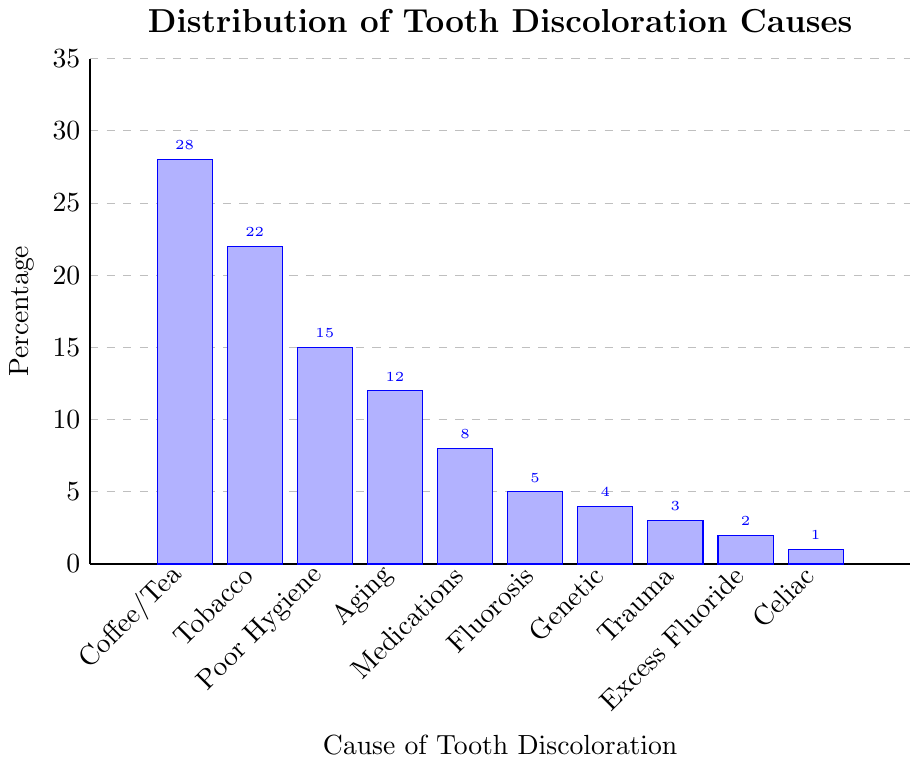Which cause of tooth discoloration has the highest percentage? The bar representing the cause "Coffee/Tea Stains" is the tallest, indicating that it has the highest percentage.
Answer: Coffee/Tea Stains What is the total percentage of tooth discoloration causes due to poor oral hygiene and aging? From the chart, Poor Oral Hygiene is 15% and Aging is 12%. Adding these values together gives 15% + 12% = 27%.
Answer: 27% Which cause of tooth discoloration has the lowest percentage? The bar representing "Celiac Disease" is the shortest, indicating that it has the lowest percentage.
Answer: Celiac Disease How much greater is the percentage of discoloration caused by Tobacco Use compared to Genetic Factors? The percentage for Tobacco Use is 22% and for Genetic Factors is 4%. The difference is 22% - 4% = 18%.
Answer: 18% What is the median percentage value of the displayed causes of tooth discoloration? Arrange the percentages in ascending order: 1, 2, 3, 4, 5, 8, 12, 15, 22, 28. The median is the average of the middle two values (5 and 8), so (5+8)/2 = 6.5%.
Answer: 6.5% Which of the two causes, Fluorosis or Medications, has a higher percentage and by how much? Fluorosis is 5% and Medications is 8%. Medications is higher by 8% - 5% = 3%.
Answer: Medications by 3% What is the combined percentage of all causes of tooth discoloration related to fluorosis (Fluorosis and Excessive Fluoride)? Fluorosis is 5% and Excessive Fluoride is 2%. Combined, they give 5% + 2% = 7%.
Answer: 7% How many causes of tooth discoloration have a percentage greater than 10%? From the chart, Coffee/Tea Stains (28%), Tobacco Use (22%), Poor Oral Hygiene (15%), and Aging (12%) all have percentages greater than 10%. This totals to 4 causes.
Answer: 4 